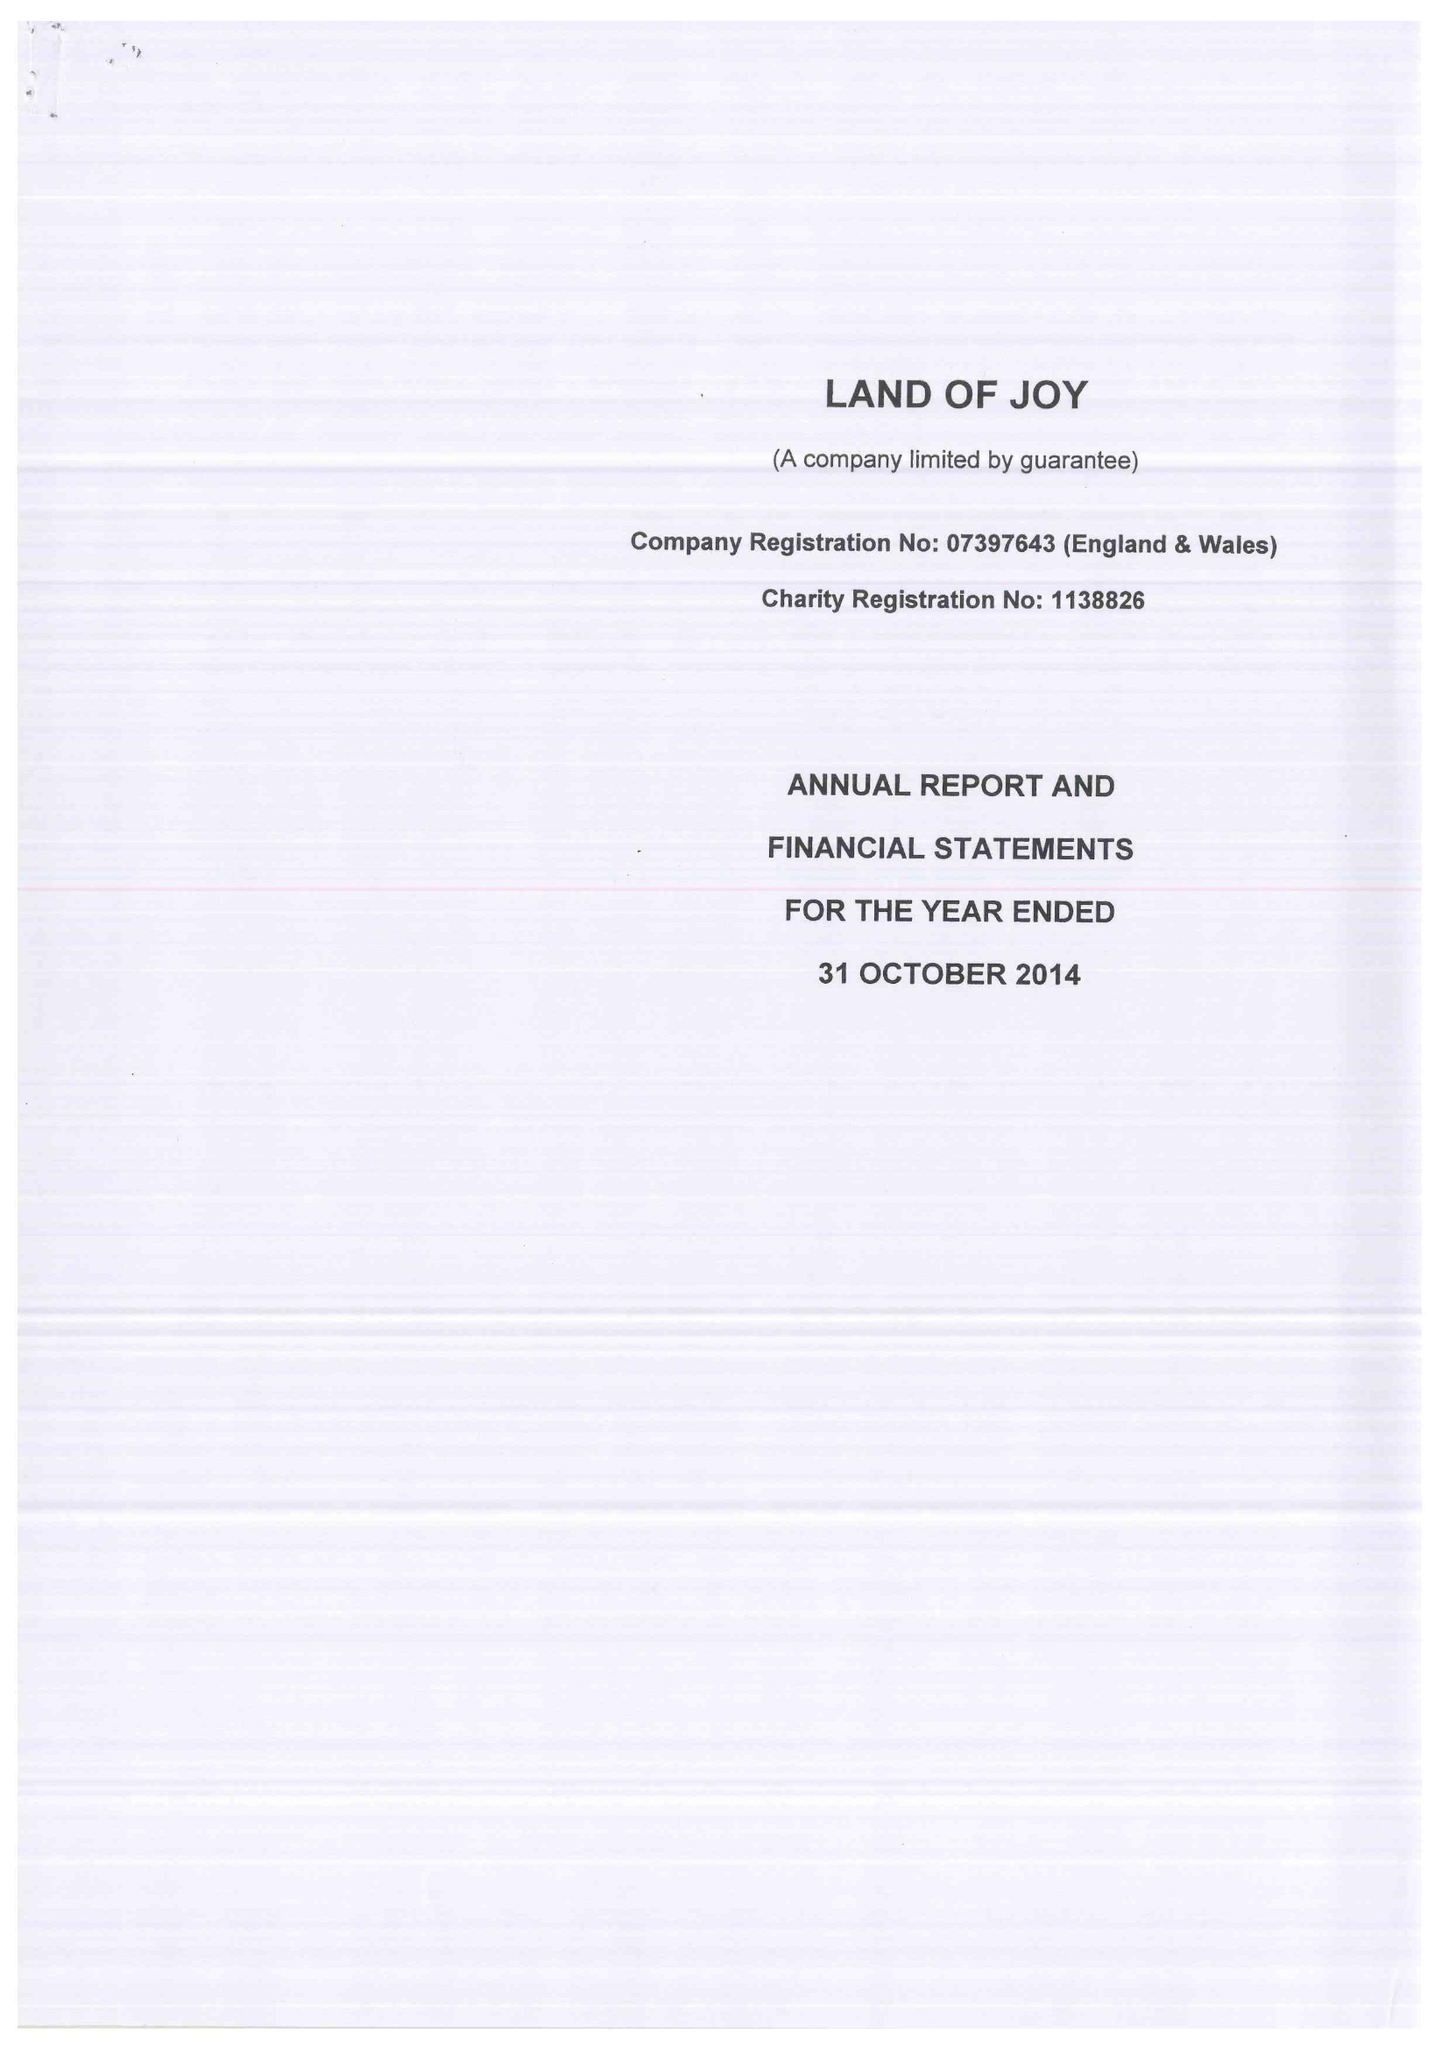What is the value for the address__postcode?
Answer the question using a single word or phrase. NE48 1PP 